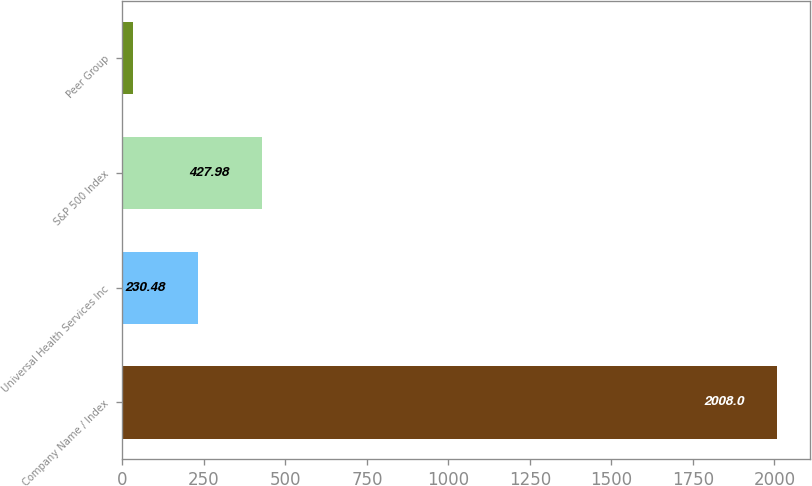Convert chart to OTSL. <chart><loc_0><loc_0><loc_500><loc_500><bar_chart><fcel>Company Name / Index<fcel>Universal Health Services Inc<fcel>S&P 500 Index<fcel>Peer Group<nl><fcel>2008<fcel>230.48<fcel>427.98<fcel>32.98<nl></chart> 